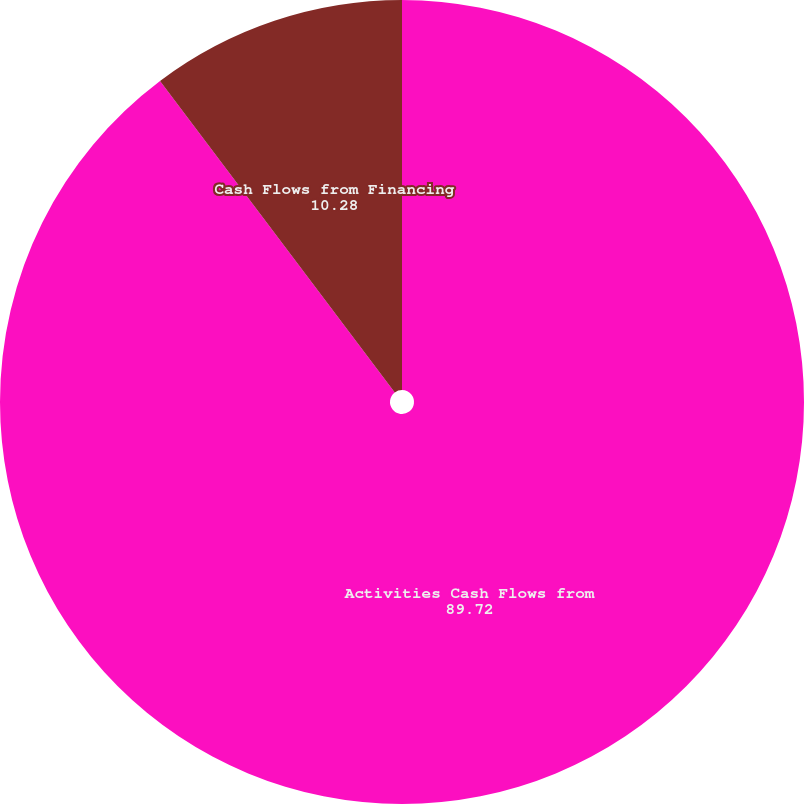<chart> <loc_0><loc_0><loc_500><loc_500><pie_chart><fcel>Activities Cash Flows from<fcel>Cash Flows from Financing<nl><fcel>89.72%<fcel>10.28%<nl></chart> 